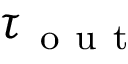Convert formula to latex. <formula><loc_0><loc_0><loc_500><loc_500>\tau _ { o u t }</formula> 